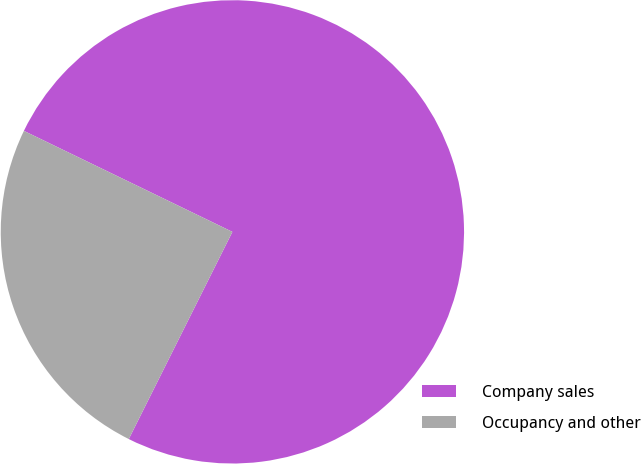Convert chart to OTSL. <chart><loc_0><loc_0><loc_500><loc_500><pie_chart><fcel>Company sales<fcel>Occupancy and other<nl><fcel>75.2%<fcel>24.8%<nl></chart> 